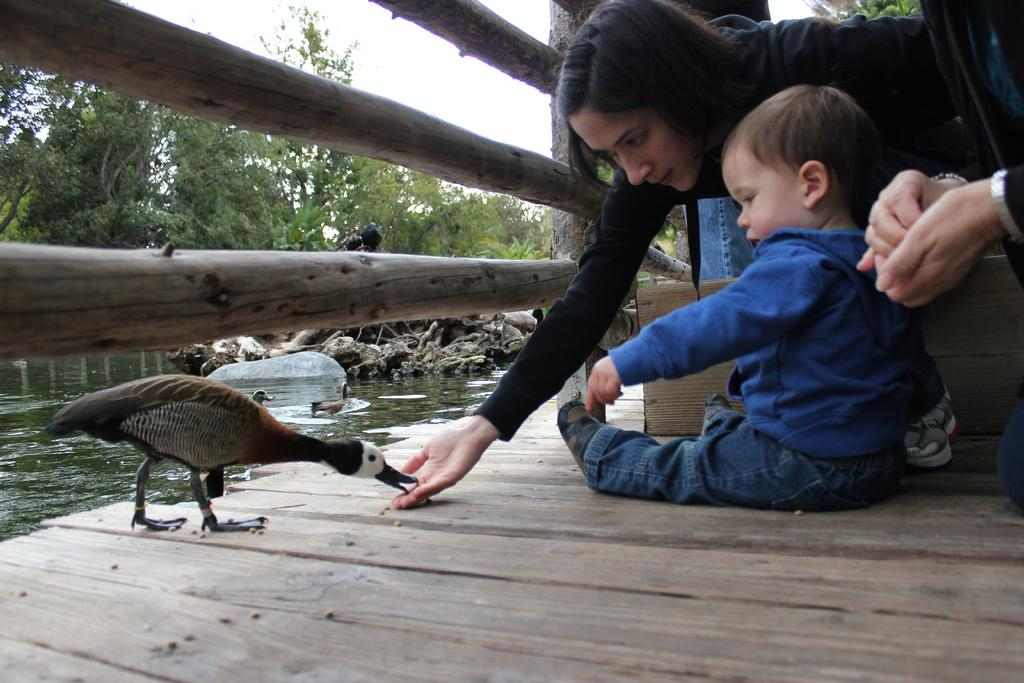Who is present in the image? There is a woman and a kid in the image. What is the bird doing in the image? The bird is eating food in the image. What can be seen in the background of the image? The sky is visible in the background of the image. What type of natural elements are present in the image? There are trees and water visible in the image. What is the purpose of the fence in the image? The fence serves as a boundary or barrier in the image. What type of authority is present in the image? There is no authority figure present in the image. --- Facts: 1. There is a man in the image. 12. There is a dog in the image. 13. The man is holding a leash in the image. 14. The dog is wearing a collar in the image. 15. There is a park in the background of the image. 16. There are trees in the background of the image. Absurd Topics: submarine, chessboard, dance Conversation: Who is present in the image? There is a man in the image. What is the man holding in the image? The man is holding a leash in the image. What type of animal is present in the image? There is a dog in the image. What is the dog wearing in the image? The dog is wearing a collar in the image. What can be seen in the background of the image? There is a park in the background of the image. What type of natural elements are present in the background of the image? There are trees in the background of the image. Reasoning: Let's think step by step in order to produce the conversation. We start by identifying the main subjects in the image, which are the man and the dog. Then, we describe the actions and characteristics of these subjects, ensuring that each question can be answered definitively with the information given. We avoid yes/no questions and ensure that the language is simple and clear. Absurd Question/Answer: Where is the submarine located in the image? There is no submarine present in the image. --- Facts: 11. There is a car in the image. 12. The car is parked on the street in the image. 13. There are other cars parked on the street in the image. 14. There is a traffic light in the image. 15. There is a pedestrian crossing in the image. 16. There are buildings in the background of the image. Absurd Topics: unicorn, rainbow, parade Conversation: What type of vehicle is present in the image? There is a car in the image. How is the car positioned in the image? The car is parked on the street in the image. 